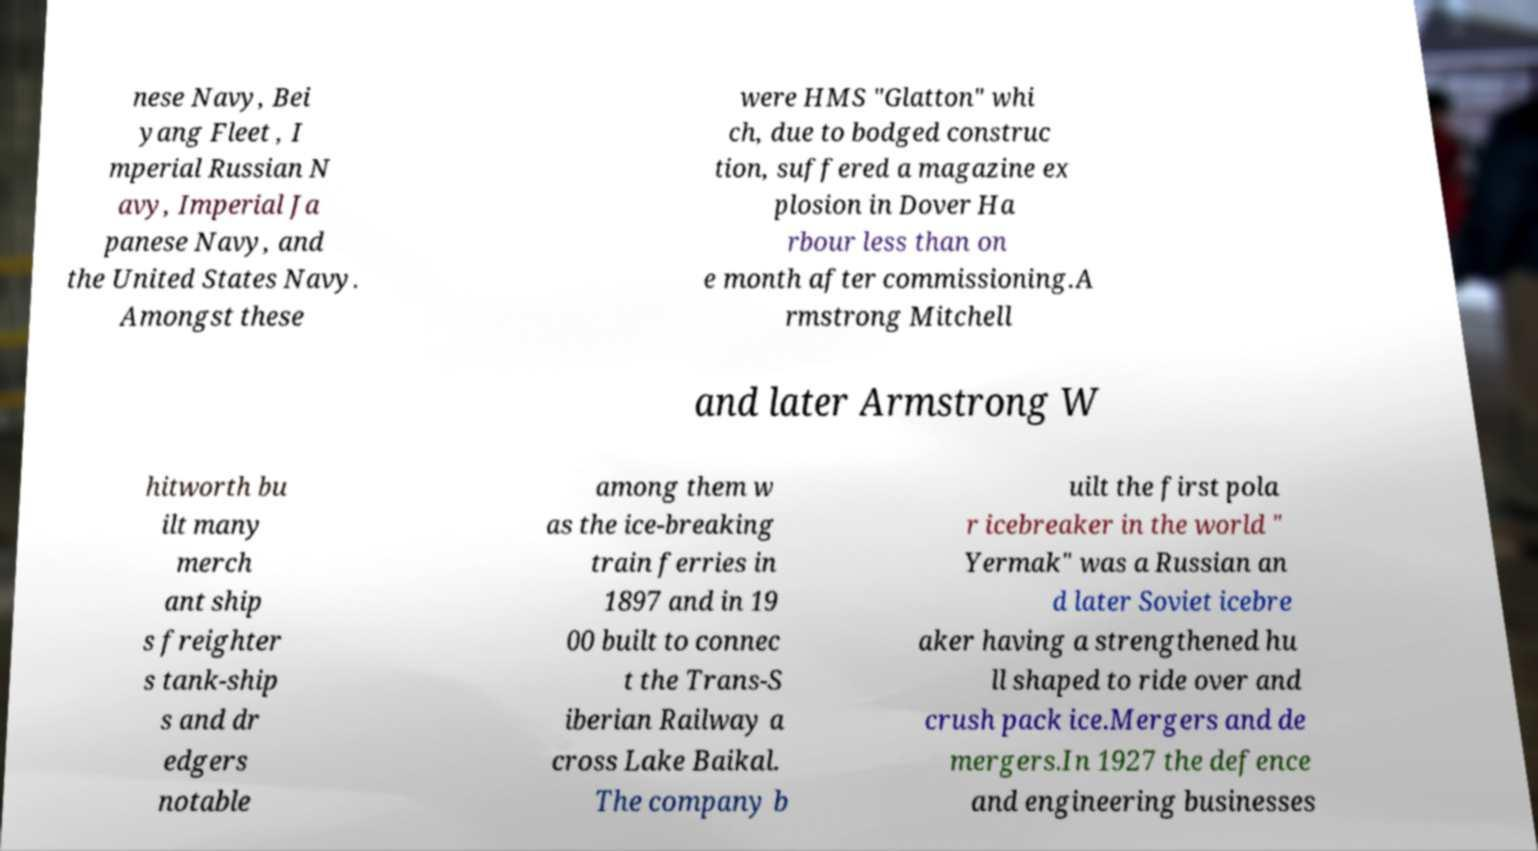Please read and relay the text visible in this image. What does it say? nese Navy, Bei yang Fleet , I mperial Russian N avy, Imperial Ja panese Navy, and the United States Navy. Amongst these were HMS "Glatton" whi ch, due to bodged construc tion, suffered a magazine ex plosion in Dover Ha rbour less than on e month after commissioning.A rmstrong Mitchell and later Armstrong W hitworth bu ilt many merch ant ship s freighter s tank-ship s and dr edgers notable among them w as the ice-breaking train ferries in 1897 and in 19 00 built to connec t the Trans-S iberian Railway a cross Lake Baikal. The company b uilt the first pola r icebreaker in the world " Yermak" was a Russian an d later Soviet icebre aker having a strengthened hu ll shaped to ride over and crush pack ice.Mergers and de mergers.In 1927 the defence and engineering businesses 